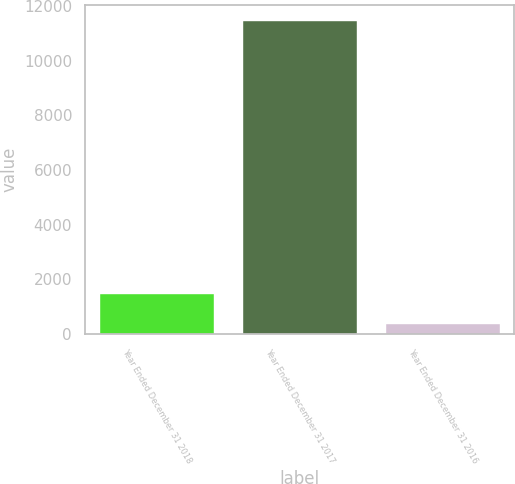Convert chart to OTSL. <chart><loc_0><loc_0><loc_500><loc_500><bar_chart><fcel>Year Ended December 31 2018<fcel>Year Ended December 31 2017<fcel>Year Ended December 31 2016<nl><fcel>1477.5<fcel>11463<fcel>368<nl></chart> 